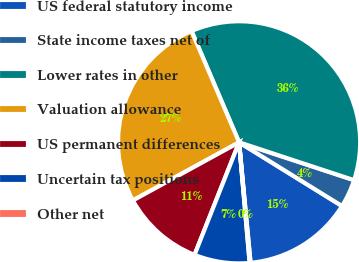Convert chart. <chart><loc_0><loc_0><loc_500><loc_500><pie_chart><fcel>US federal statutory income<fcel>State income taxes net of<fcel>Lower rates in other<fcel>Valuation allowance<fcel>US permanent differences<fcel>Uncertain tax positions<fcel>Other net<nl><fcel>14.67%<fcel>3.76%<fcel>36.49%<fcel>26.54%<fcel>11.03%<fcel>7.39%<fcel>0.12%<nl></chart> 